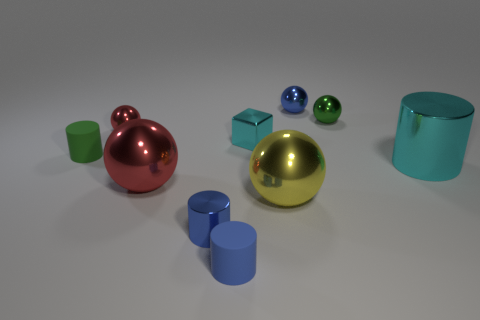What number of other things are there of the same size as the blue matte cylinder? Aside from the blue matte cylinder, there are six other objects that appear to share its size: two glossy spheres, two shiny cylinders, a metallic cube, and a metallic sphere. 